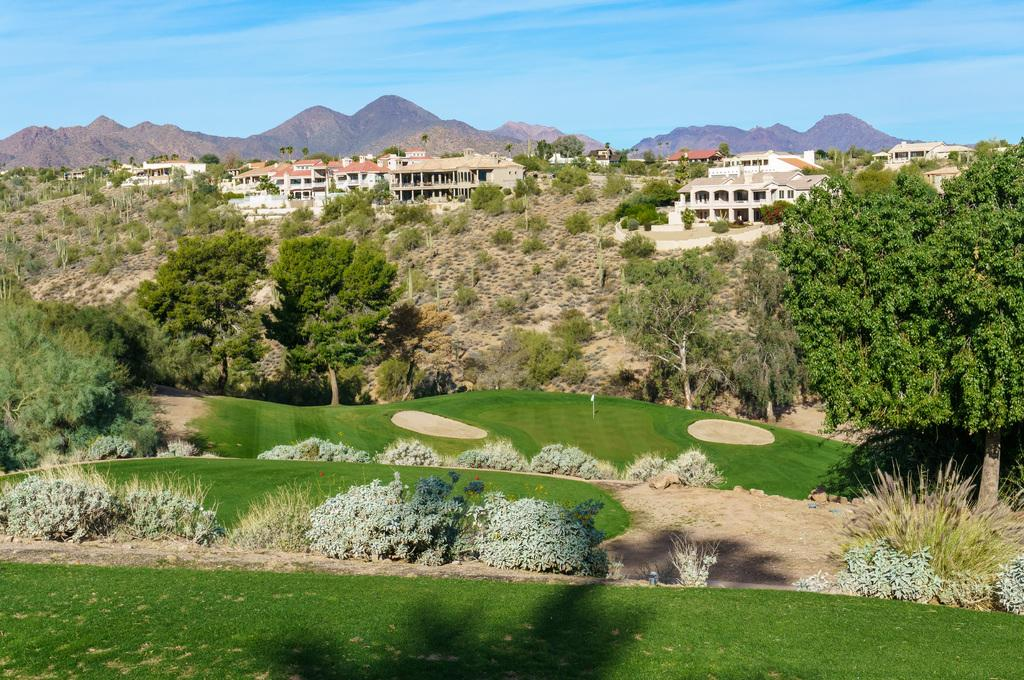What type of ground surface is visible in the image? There is grass on the ground in the image. What can be seen in the background of the image? There are plants, trees, buildings, mountains, and the sky visible in the background of the image. What type of letter is being delivered by the crow in the image? There is no crow or letter present in the image. What part of the brain can be seen in the image? There is no brain visible in the image. 